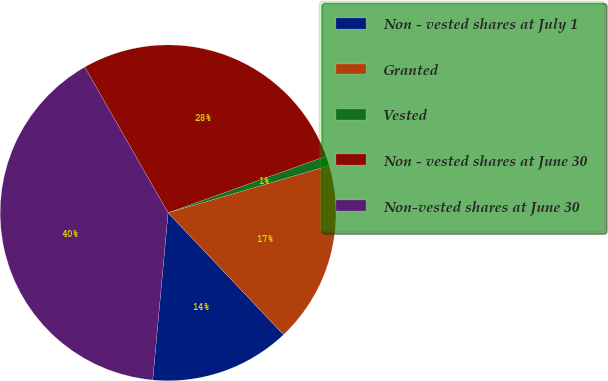<chart> <loc_0><loc_0><loc_500><loc_500><pie_chart><fcel>Non - vested shares at July 1<fcel>Granted<fcel>Vested<fcel>Non - vested shares at June 30<fcel>Non-vested shares at June 30<nl><fcel>13.53%<fcel>17.46%<fcel>0.94%<fcel>27.79%<fcel>40.28%<nl></chart> 